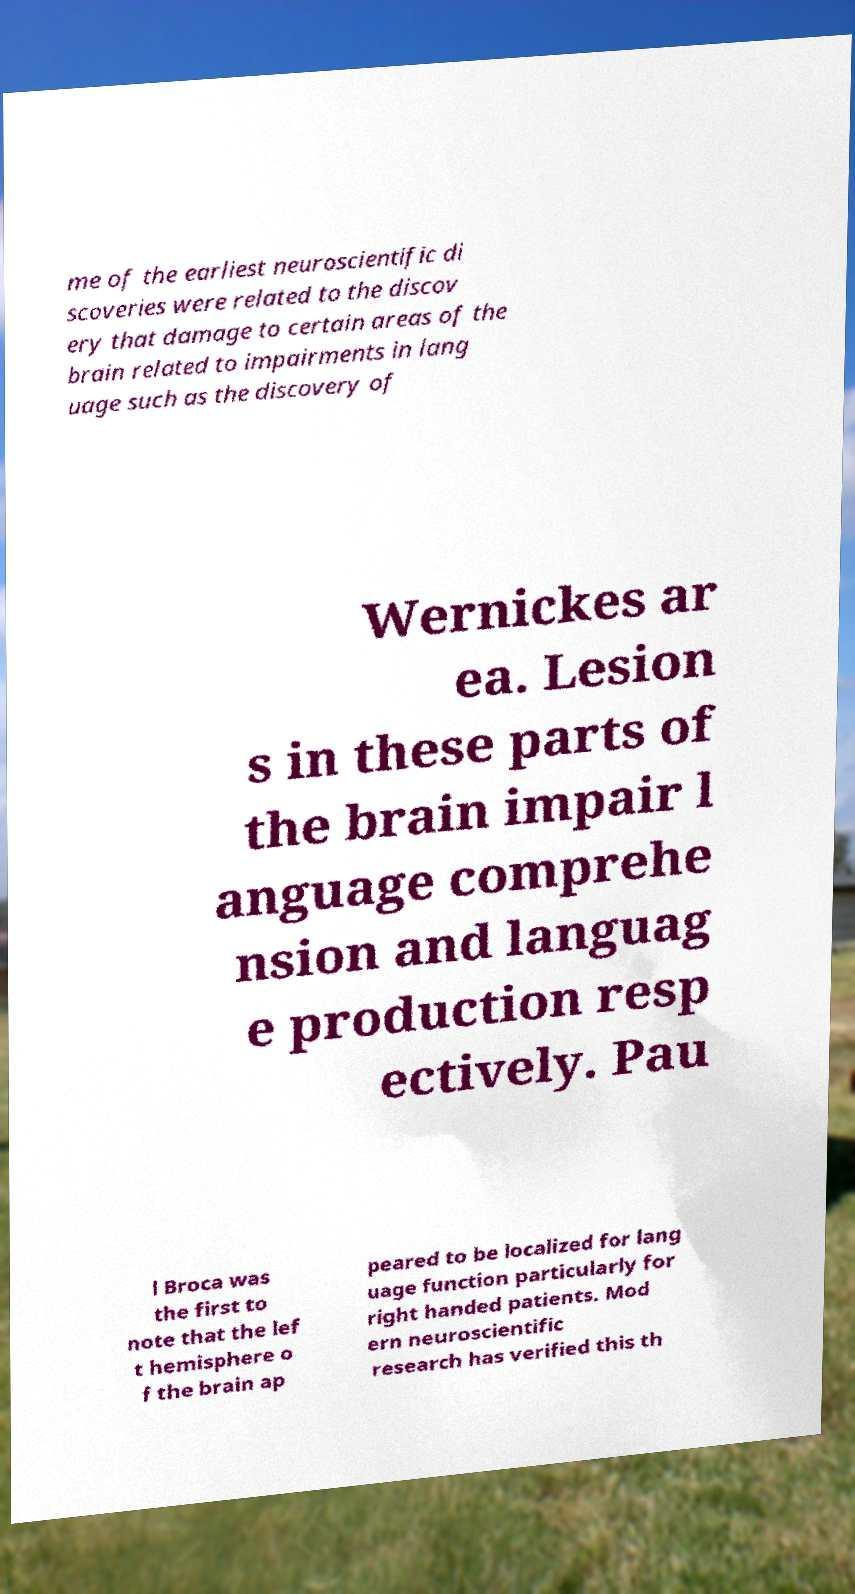Could you assist in decoding the text presented in this image and type it out clearly? me of the earliest neuroscientific di scoveries were related to the discov ery that damage to certain areas of the brain related to impairments in lang uage such as the discovery of Wernickes ar ea. Lesion s in these parts of the brain impair l anguage comprehe nsion and languag e production resp ectively. Pau l Broca was the first to note that the lef t hemisphere o f the brain ap peared to be localized for lang uage function particularly for right handed patients. Mod ern neuroscientific research has verified this th 